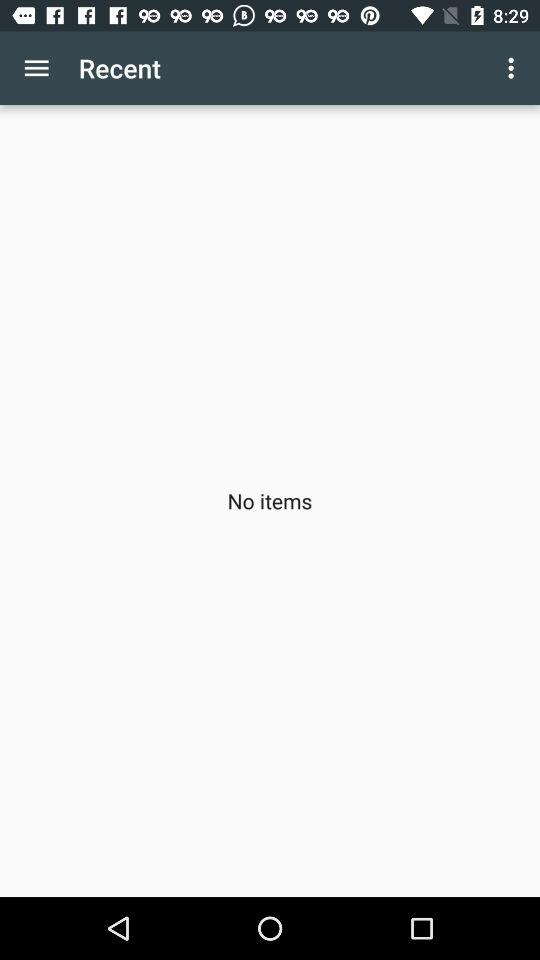Is there any item? There is no item. 